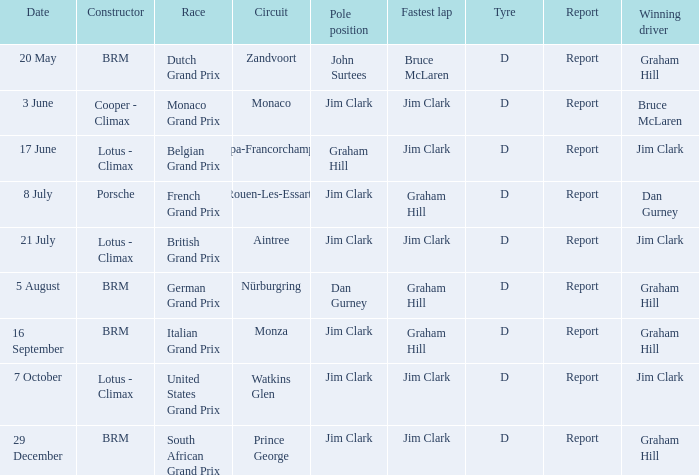What is the date of the circuit of nürburgring, which had Graham Hill as the winning driver? 5 August. 